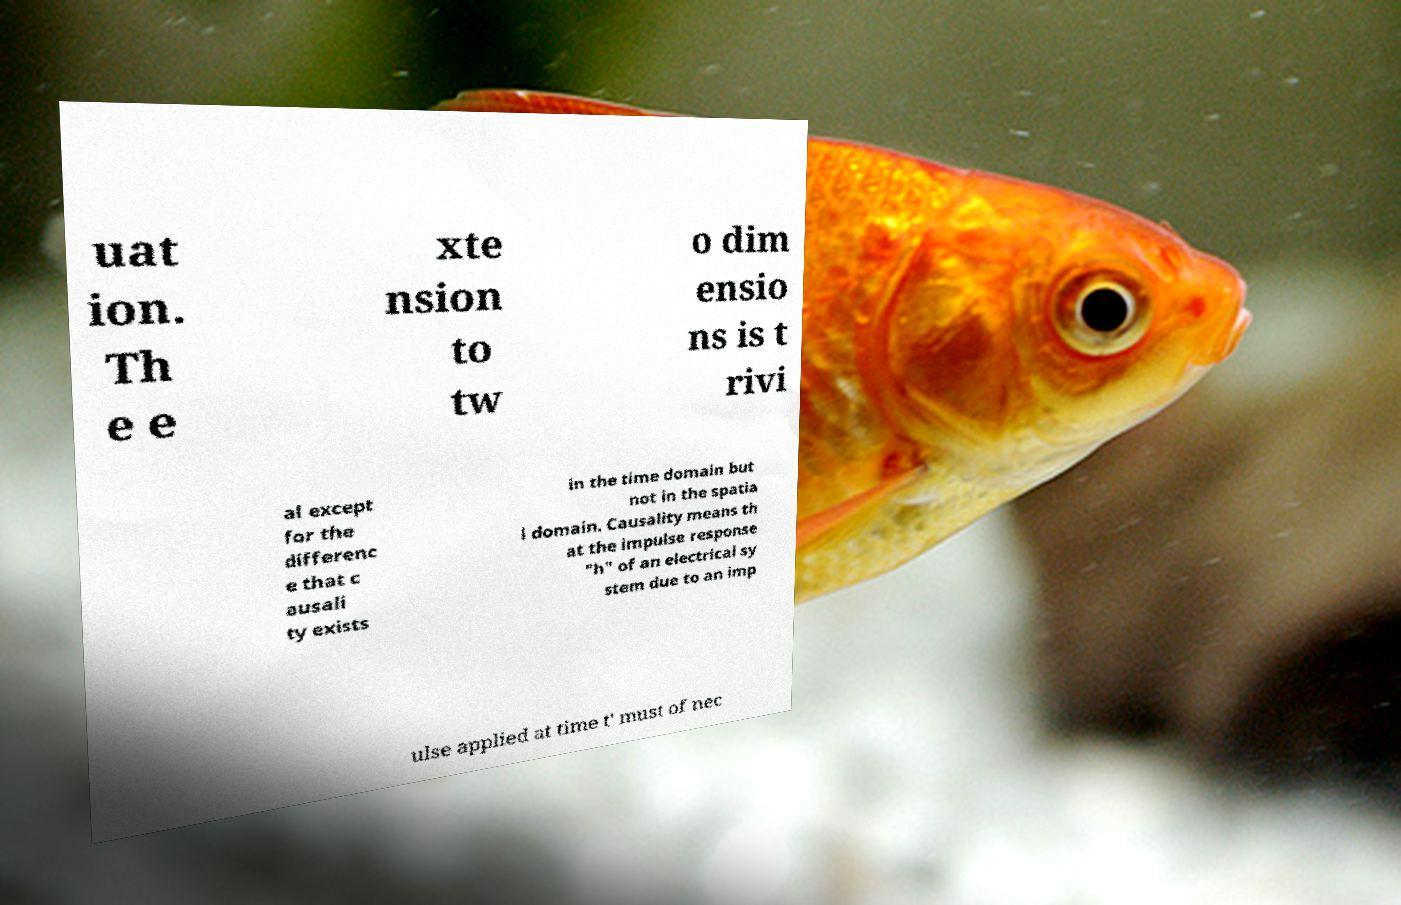Could you extract and type out the text from this image? uat ion. Th e e xte nsion to tw o dim ensio ns is t rivi al except for the differenc e that c ausali ty exists in the time domain but not in the spatia l domain. Causality means th at the impulse response "h" of an electrical sy stem due to an imp ulse applied at time t' must of nec 